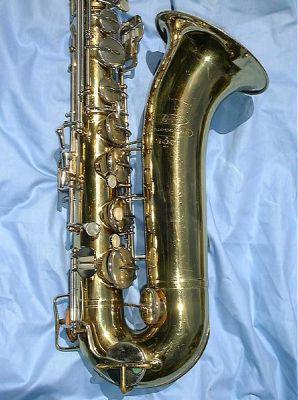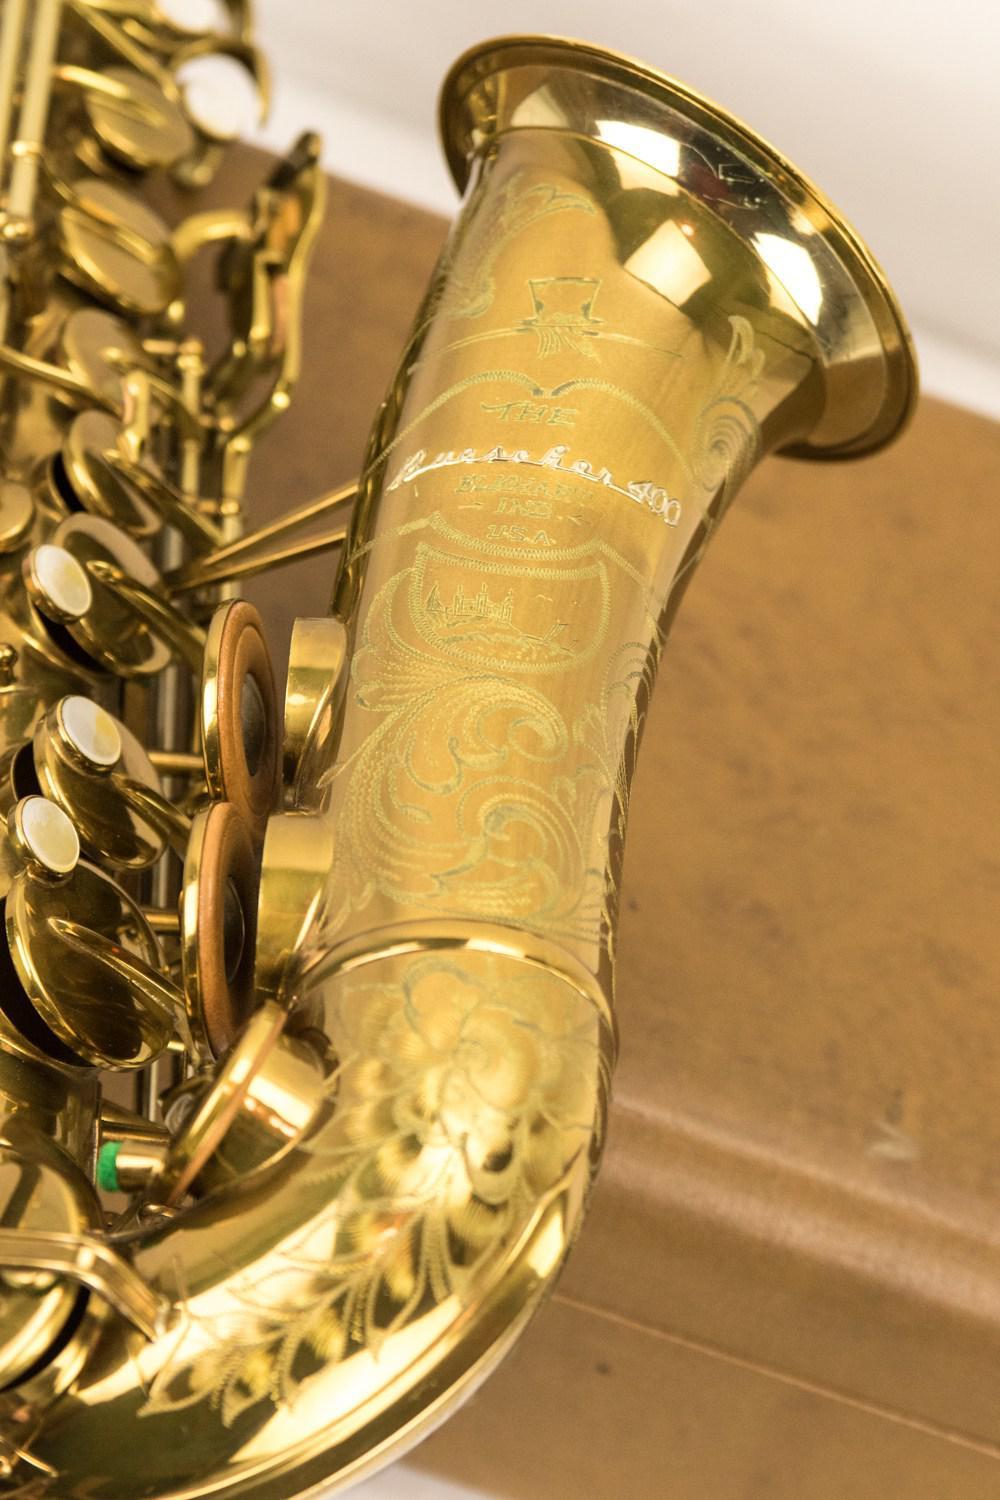The first image is the image on the left, the second image is the image on the right. Examine the images to the left and right. Is the description "A word and number are engraved on the saxophone in the image on the right." accurate? Answer yes or no. No. The first image is the image on the left, the second image is the image on the right. Assess this claim about the two images: "One image shows the gold-colored bell of a saxophone turned leftward, and the other image shows decorative scrolled etching on a gold-colored instrument.". Correct or not? Answer yes or no. No. 